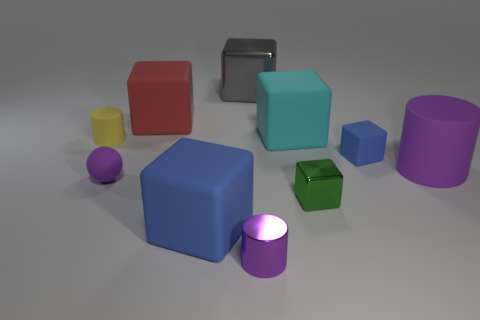Subtract all red cubes. How many cubes are left? 5 Subtract all blue matte cubes. How many cubes are left? 4 Subtract all purple cubes. Subtract all brown cylinders. How many cubes are left? 6 Subtract all cylinders. How many objects are left? 7 Subtract all large metallic blocks. Subtract all purple matte balls. How many objects are left? 8 Add 1 small green blocks. How many small green blocks are left? 2 Add 1 tiny matte things. How many tiny matte things exist? 4 Subtract 0 cyan cylinders. How many objects are left? 10 